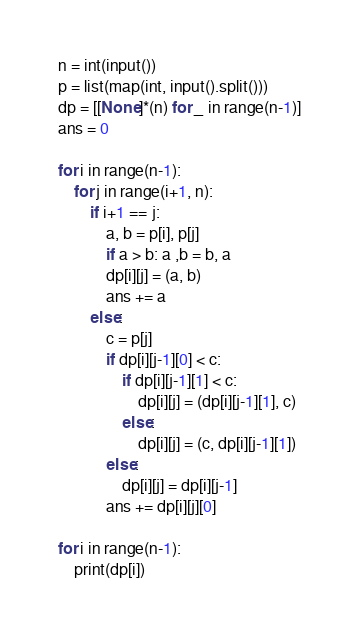<code> <loc_0><loc_0><loc_500><loc_500><_Python_>n = int(input())
p = list(map(int, input().split()))
dp = [[None]*(n) for _ in range(n-1)]
ans = 0

for i in range(n-1):
    for j in range(i+1, n):
        if i+1 == j:
            a, b = p[i], p[j]
            if a > b: a ,b = b, a
            dp[i][j] = (a, b)
            ans += a
        else:
            c = p[j]
            if dp[i][j-1][0] < c:
                if dp[i][j-1][1] < c:
                    dp[i][j] = (dp[i][j-1][1], c)
                else:
                    dp[i][j] = (c, dp[i][j-1][1])
            else:
                dp[i][j] = dp[i][j-1]
            ans += dp[i][j][0]

for i in range(n-1):
    print(dp[i])
</code> 